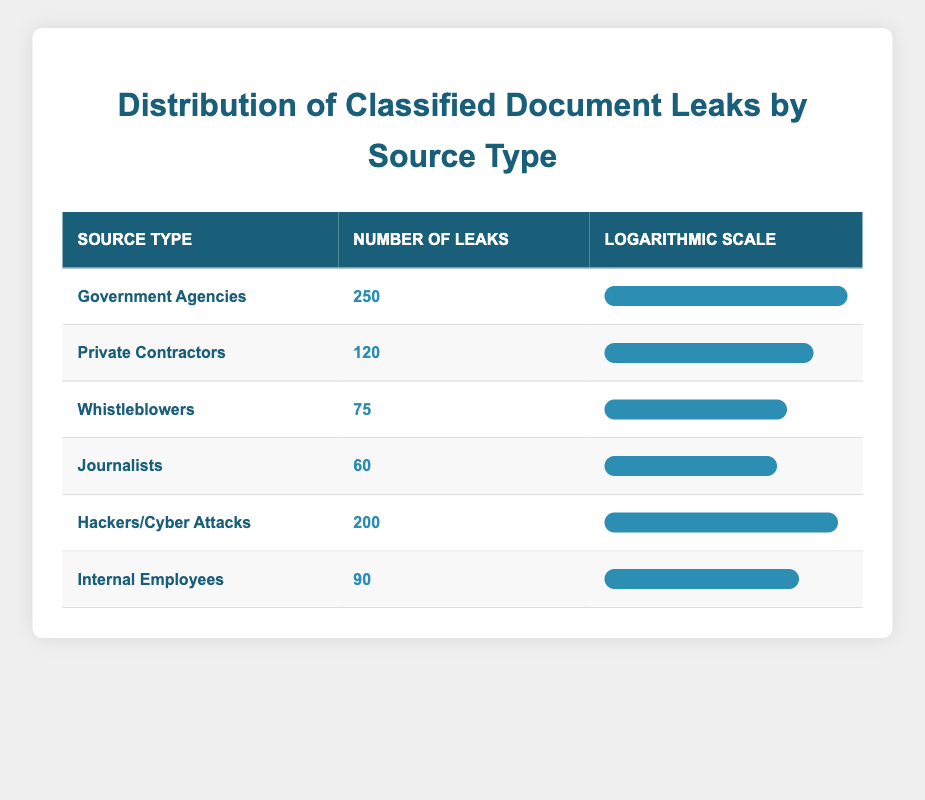What is the highest number of leaks reported in a single source type? The table lists "Government Agencies" with 250 leaks as the highest number among all source types. Therefore, this is the highest count depicted in the table.
Answer: 250 Which source type has the lowest number of leaks? According to the table, "Journalists" has the lowest number of leaks at 60, making it the least frequent source of classified document leaks.
Answer: 60 What is the total number of leaks from all sources combined? Adding all the leaks from the table (250 + 120 + 75 + 60 + 200 + 90) gives a total of 795 leaked documents. Hence, the total number of leaks across all sources is 795.
Answer: 795 Determine whether "Whistleblowers" report more leaks than "Internal Employees". From the table, "Whistleblowers" has 75 leaks while "Internal Employees" has 90 leaks. Therefore, the statement is false.
Answer: No What is the difference in the number of leaks between "Government Agencies" and "Hackers/Cyber Attacks"? "Government Agencies" have 250 leaks and "Hackers/Cyber Attacks" have 200 leaks. The difference is calculated as 250 - 200 = 50 leaks. Therefore, the difference in leaks between these two sources is 50.
Answer: 50 Calculate the average number of leaks per source type. There are 6 source types in total, and the sum of all leaks is 795. To find the average, divide the total number of leaks (795) by the number of source types (6), which is approximately 132.5. Thus, the average number of leaks per source type is 132.5.
Answer: 132.5 Which source type accounts for nearly a third of the total leaks? To find the source type that accounts for nearly a third of the total (795), we calculate one third of 795, which is approximately 265. Since no source type meets this, we determine that none of the sources account for nearly a third.
Answer: No Which source type has a leak value greater than the average number of leaks? The average number of leaks is approximately 132.5. "Government Agencies" (250), "Hackers/Cyber Attacks" (200), and "Private Contractors" (120) all exceed this average, while others do not. Therefore, the source types greater than the average are "Government Agencies" and "Hackers/Cyber Attacks".
Answer: Government Agencies, Hackers/Cyber Attacks 